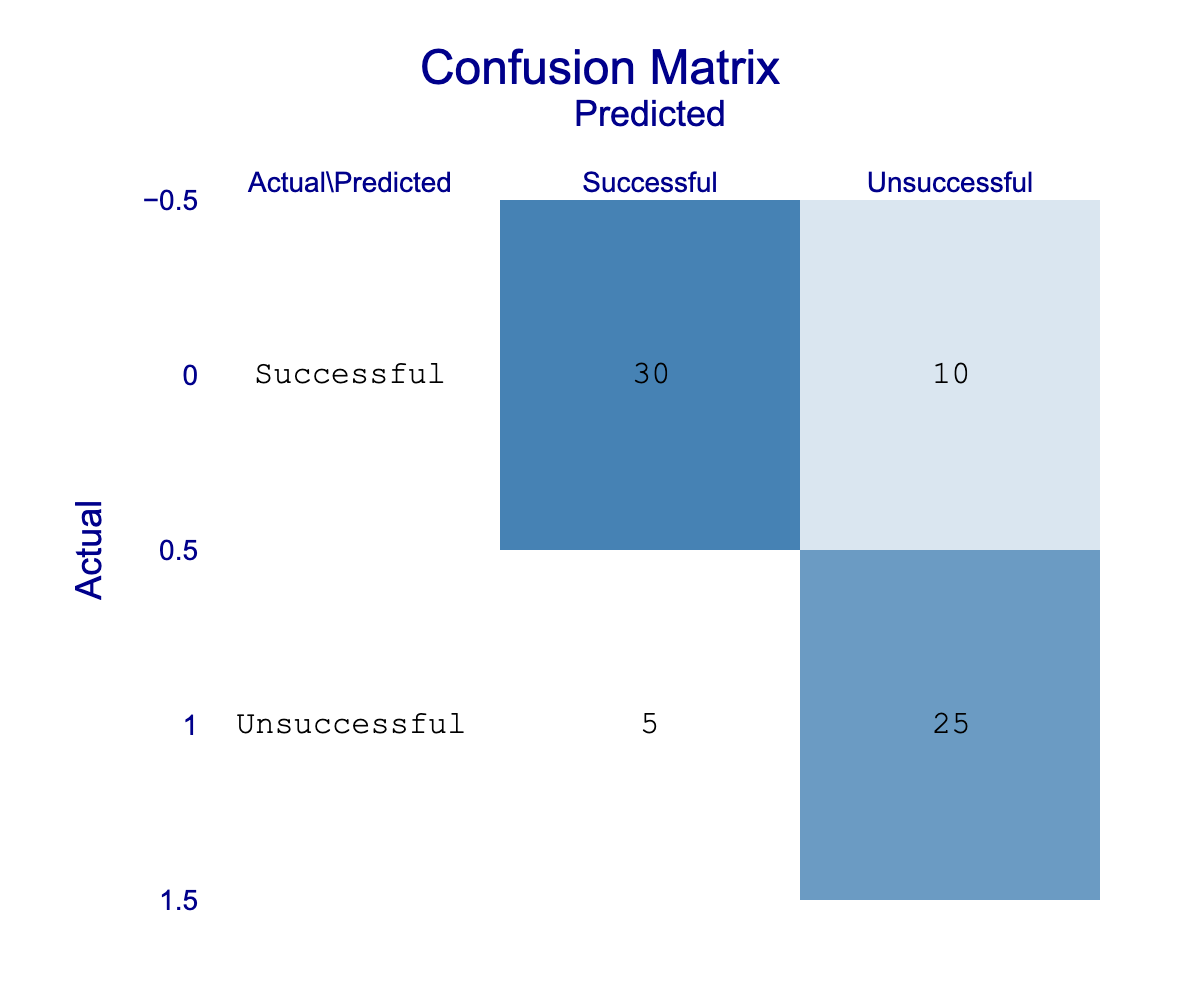What is the total number of successful projects predicted? From the table, the number of successful projects predicted is represented by the "Successful" column under "Predicted" category. According to the matrix, there are 30 projects categorized as successful.
Answer: 30 How many projects were inaccurately predicted as unsuccessful when they were actually successful? The number of projects inaccurately predicted as unsuccessful while they were actually successful is found in the "Successful" row and "Unsuccessful" column. The value is 10.
Answer: 10 What percentage of actual unsuccessful projects were correctly predicted? To find the percentage of actual unsuccessful projects that were correctly predicted, take the number of correctly predicted unsuccessful projects (25) divided by the total number of actual unsuccessful projects (25 + 5 = 30), then multiply by 100. (25/30) * 100 = 83.33%.
Answer: 83.33% Is the number of successful projects predicted greater than the number of unsuccessful projects predicted? To answer this, compare the values in the "Successful" and "Unsuccessful" columns. The successful predictions are 30, while the unsuccessful predictions are 10. Since 30 > 10, the statement is true.
Answer: Yes What is the total number of projects in the confusion matrix? The total number of projects is obtained by adding all the values in the confusion matrix: 30 + 10 + 5 + 25 = 70.
Answer: 70 What is the false negative rate for successful projects? The false negative rate can be calculated by dividing the number of actual successful projects that were predicted as unsuccessful (10) by the total number of actual successful projects (30 + 10 = 40). Therefore, the false negative rate is 10/40 = 25%.
Answer: 25% How many actual successful projects were correctly identified as successful? The number of actual successful projects that were correctly identified as successful is the value in the "Successful" row and "Successful" column, which is 30.
Answer: 30 What is the difference in the number of successful and unsuccessful predictions? The difference can be found by subtracting the number of unsuccessful predictions (10) from the number of successful predictions (30): 30 - 10 = 20.
Answer: 20 Was the total number of predicted successful projects higher than the total of predicted unsuccessful projects? By comparing the totals, the predicted successful projects are 30 and the predicted unsuccessful projects are 10. Since 30 is greater than 10, this statement is true.
Answer: Yes 